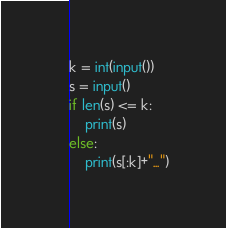Convert code to text. <code><loc_0><loc_0><loc_500><loc_500><_Python_>k = int(input())
s = input()
if len(s) <= k:
    print(s)
else:
    print(s[:k]+"...")</code> 